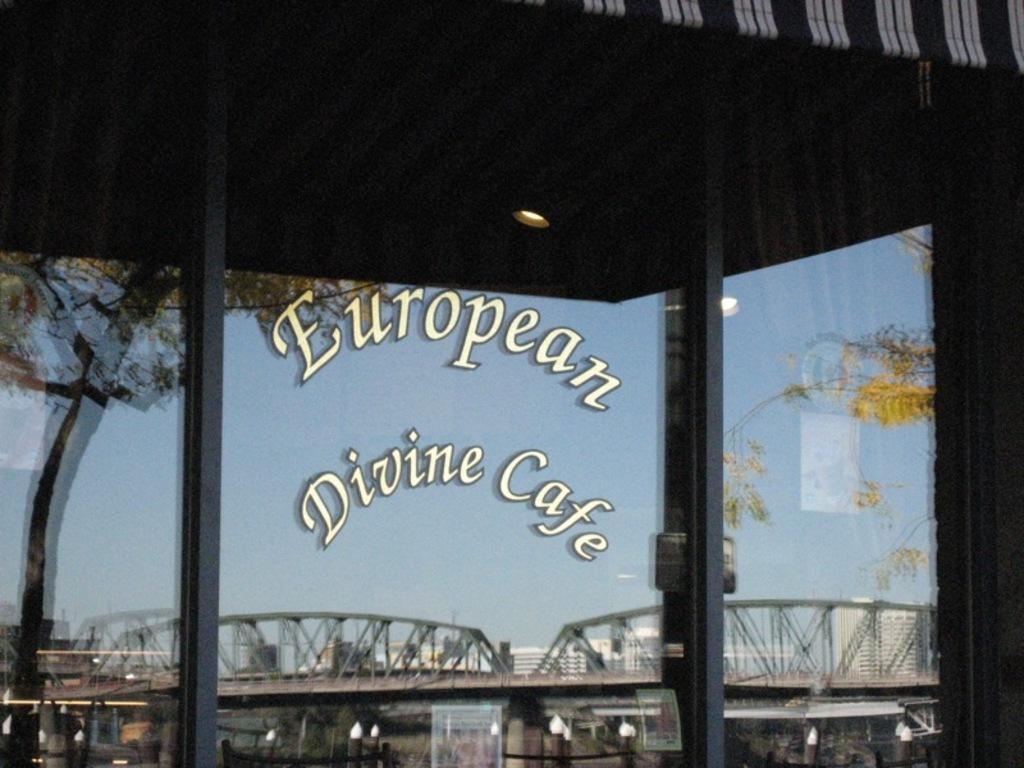In one or two sentences, can you explain what this image depicts? In this image I can see a bridge, two poles, a light, a shed and few trees. In the background I can see few buildings and the sky. 